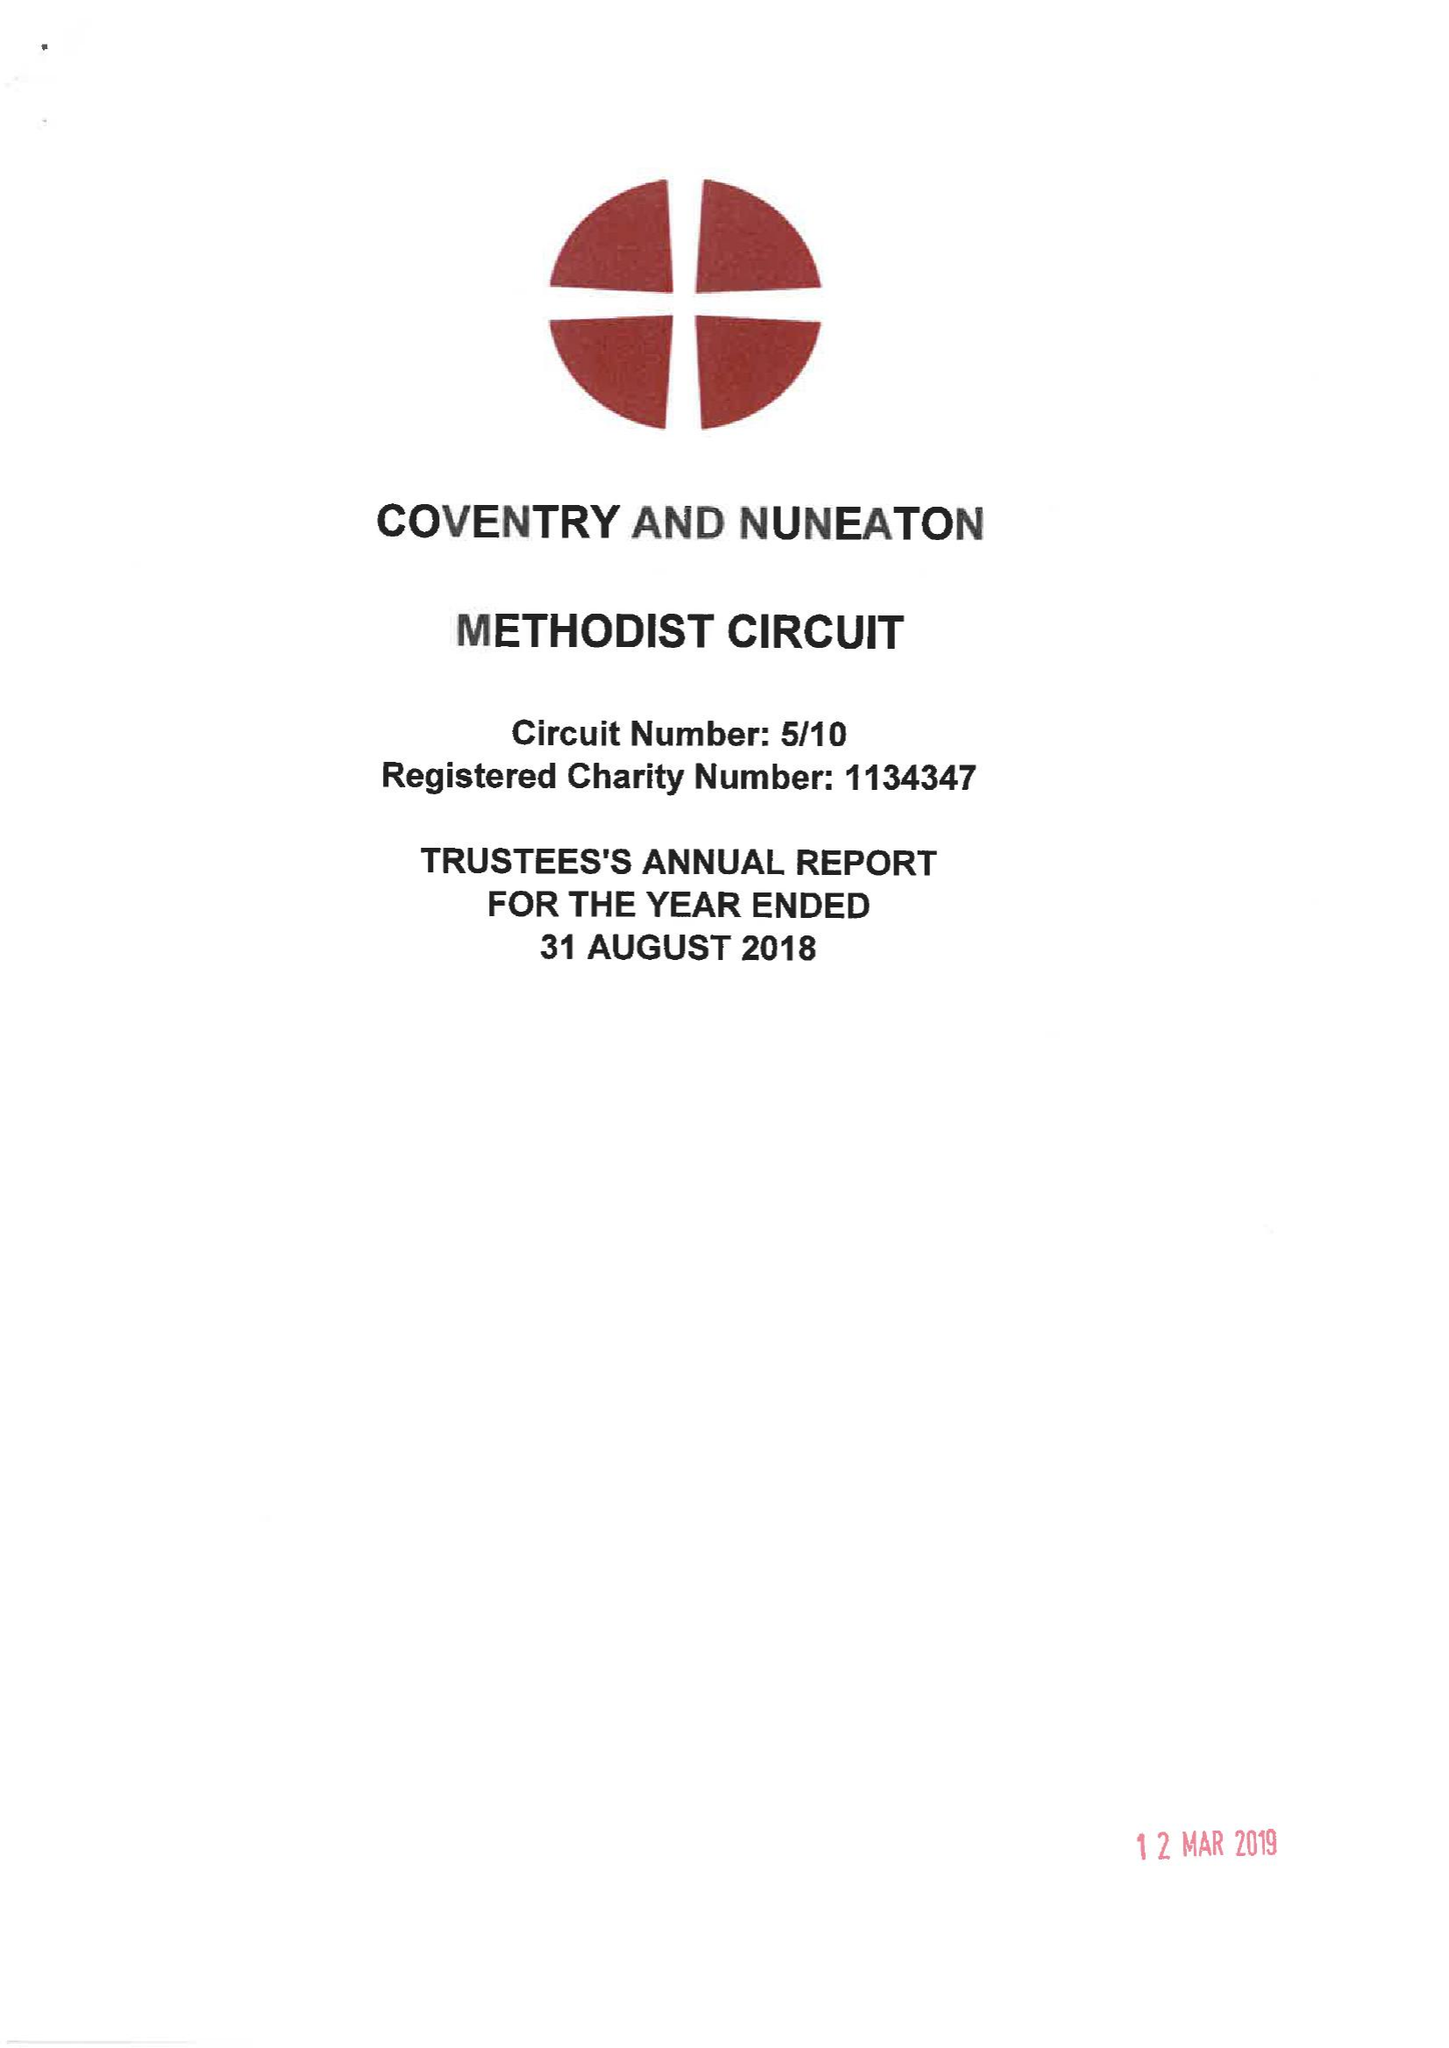What is the value for the spending_annually_in_british_pounds?
Answer the question using a single word or phrase. 397319.00 